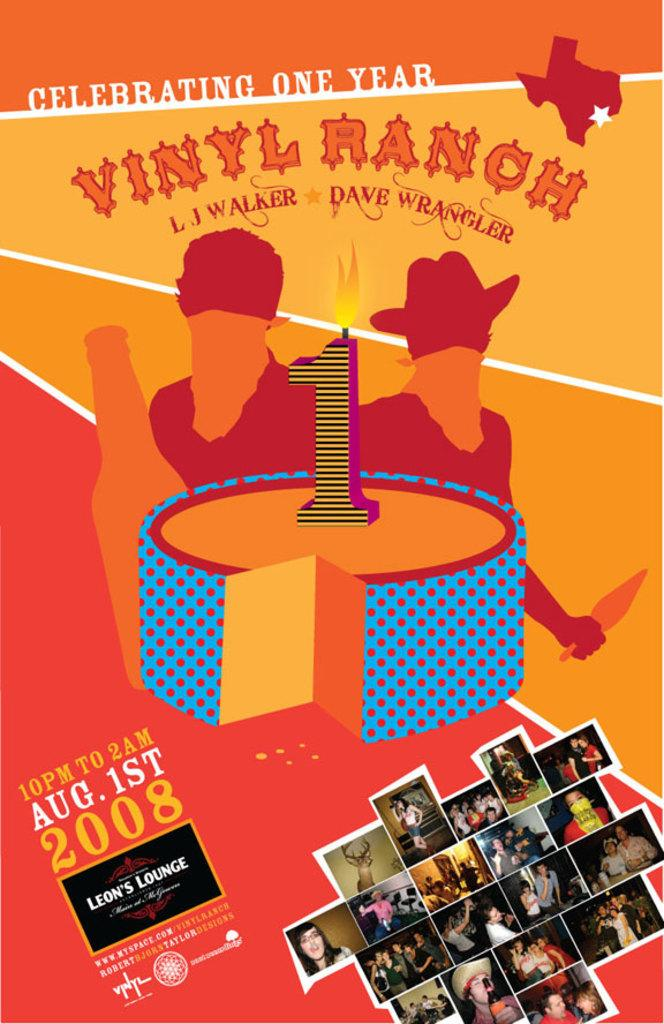What type of poster is in the image? There is an invitation poster in the image. What event is the poster for? The poster is for a one-year anniversary. Are there any images on the poster? Yes, there are photo images at the bottom of the poster. Can you see a toad working on the poster in the image? No, there is no toad or any indication of work being done on the poster in the image. 